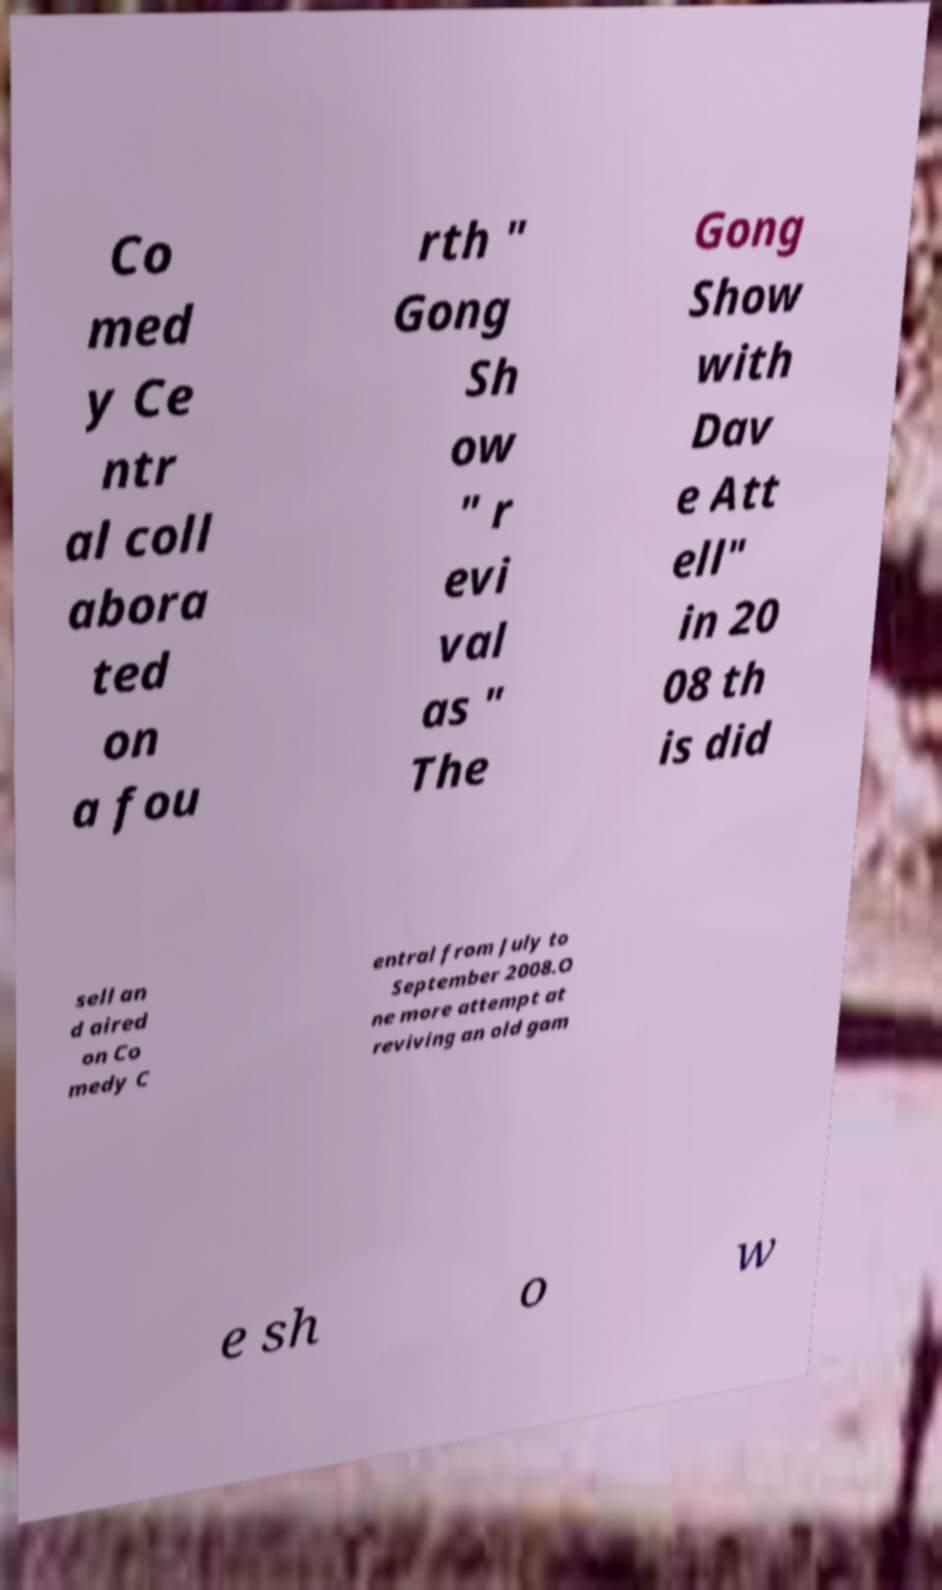Please identify and transcribe the text found in this image. Co med y Ce ntr al coll abora ted on a fou rth " Gong Sh ow " r evi val as " The Gong Show with Dav e Att ell" in 20 08 th is did sell an d aired on Co medy C entral from July to September 2008.O ne more attempt at reviving an old gam e sh o w 